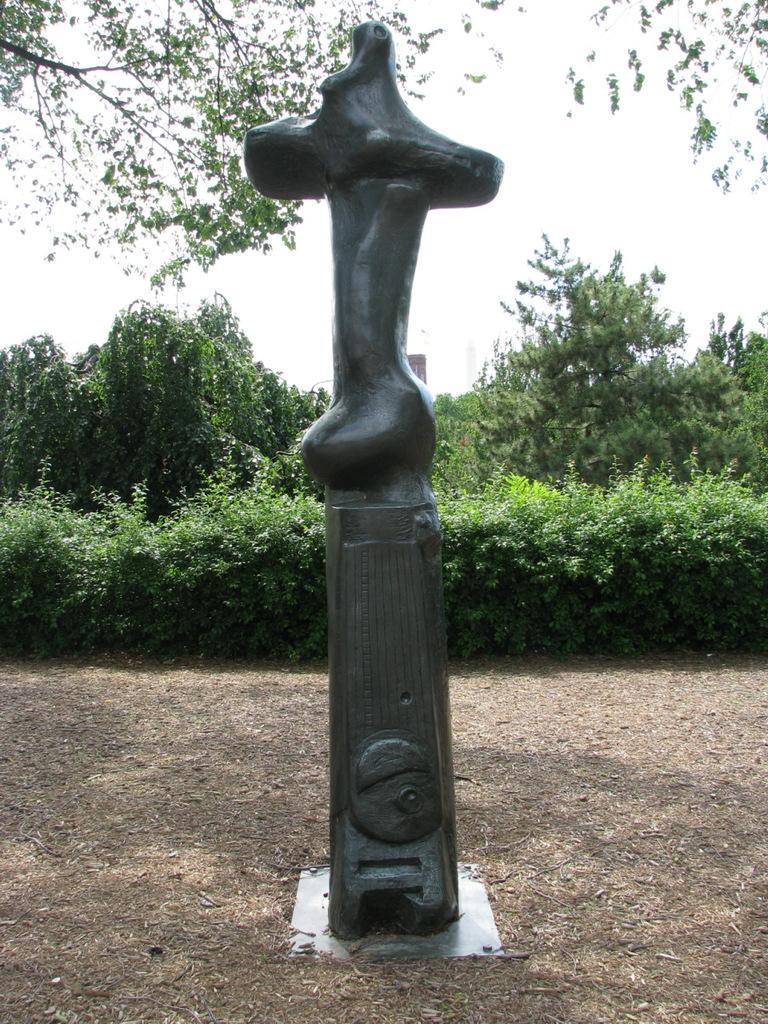How would you summarize this image in a sentence or two? In this picture there is an idol in black color which is in black color is kept on the floor and behind there are some plants and trees. 